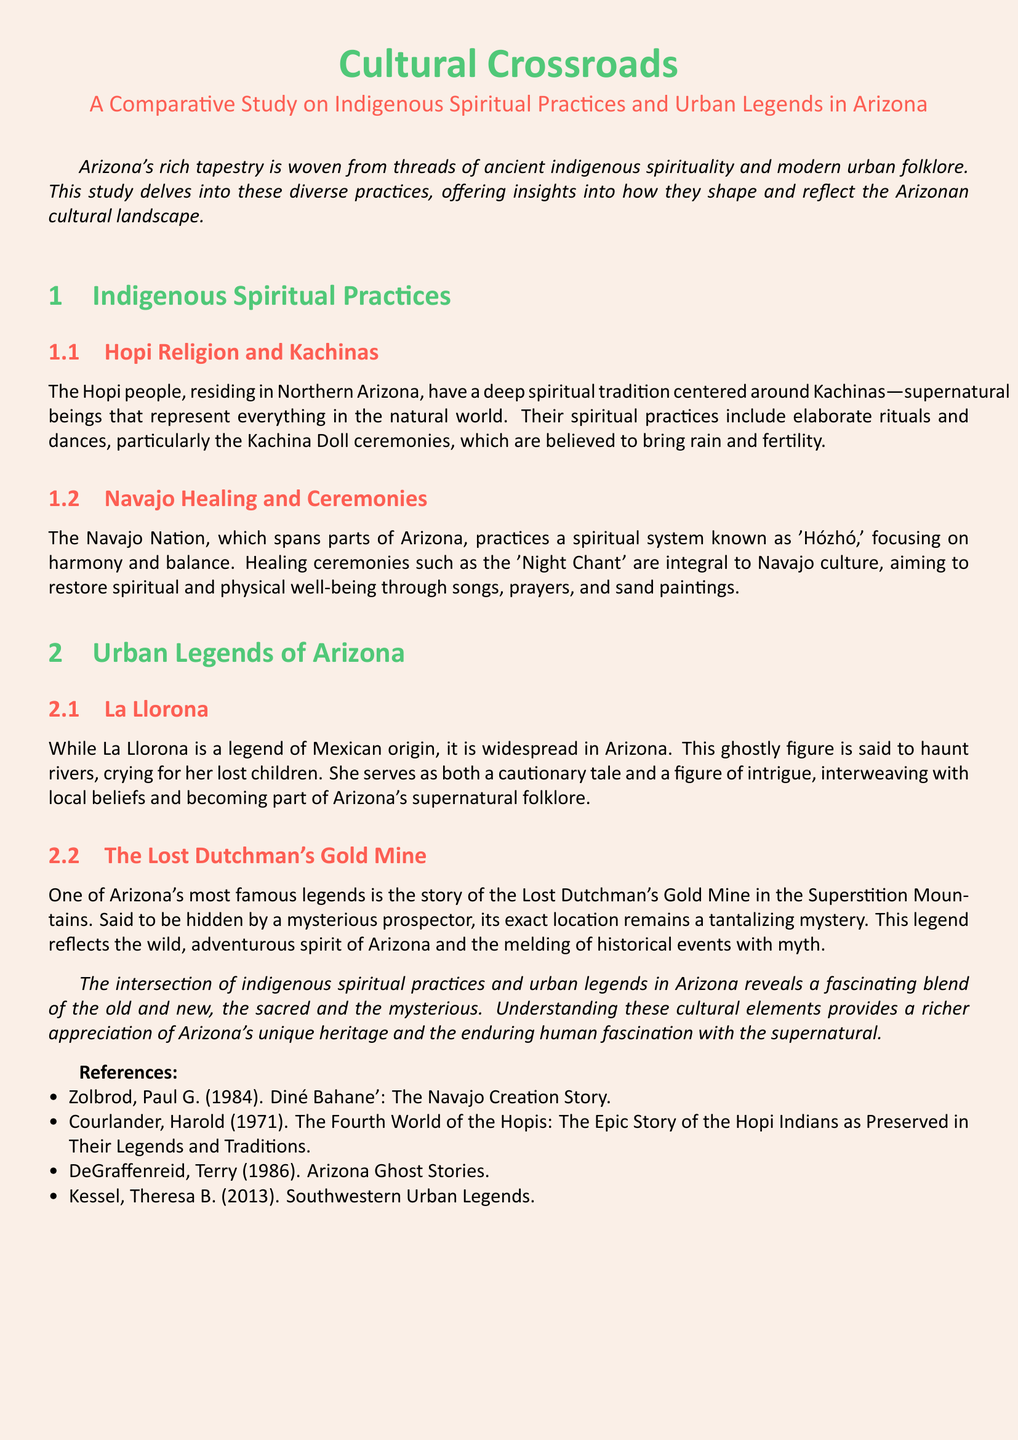What spiritual beings are central to Hopi religion? The document mentions that the Hopi people have a deep spiritual tradition centered around Kachinas—supernatural beings that represent everything in the natural world.
Answer: Kachinas What is the focus of the Navajo spiritual system? The document states that the Navajo Nation practices a spiritual system known as 'Hózhó,' which focuses on harmony and balance.
Answer: Harmony and balance Which legendary figure is said to haunt rivers in Arizona? The document describes the legend of La Llorona, a ghostly figure that is said to haunt rivers and cry for her lost children.
Answer: La Llorona What is the famed location associated with the Lost Dutchman’s legend? The document indicates that the Lost Dutchman’s Gold Mine is said to be hidden in the Superstition Mountains.
Answer: Superstition Mountains What type of ceremonies are integral to Navajo culture? The document highlights that healing ceremonies like the 'Night Chant' are integral to Navajo culture, aiming to restore spiritual and physical well-being.
Answer: Night Chant How are indigenous spiritual practices and urban legends presented in the document? The document explains that the intersection of indigenous spiritual practices and urban legends in Arizona reveals a fascinating blend of the old and new, the sacred and the mysterious.
Answer: Blend of the old and new Who authored "Diné Bahane': The Navajo Creation Story"? The document lists Paul G. Zolbrod as the author of "Diné Bahane': The Navajo Creation Story."
Answer: Paul G. Zolbrod What is a primary purpose of the Kachina Doll ceremonies? The document states that Kachina Doll ceremonies are believed to bring rain and fertility.
Answer: Bring rain and fertility 